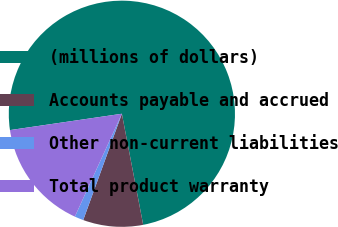Convert chart to OTSL. <chart><loc_0><loc_0><loc_500><loc_500><pie_chart><fcel>(millions of dollars)<fcel>Accounts payable and accrued<fcel>Other non-current liabilities<fcel>Total product warranty<nl><fcel>74.29%<fcel>8.57%<fcel>1.27%<fcel>15.87%<nl></chart> 